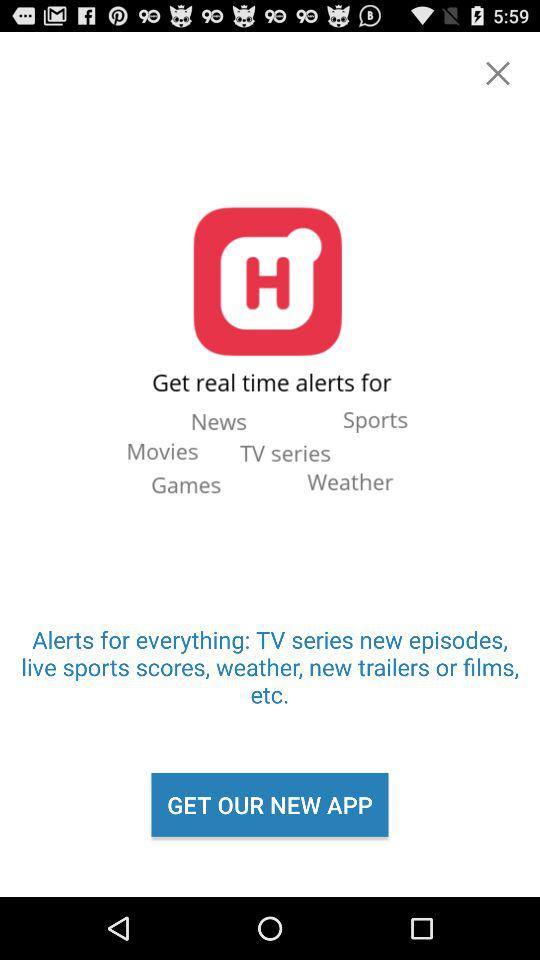What is the name of the application? The name of the application is "Hooks". 